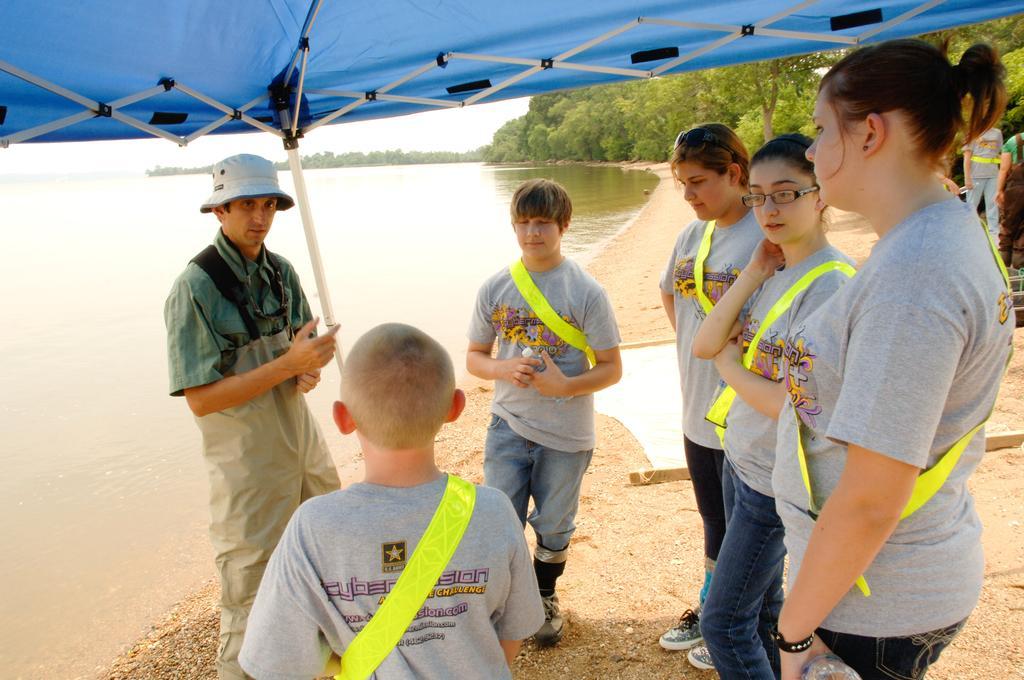How would you summarize this image in a sentence or two? In this picture we can see some people are standing, on the left side there is water, we can see trees in the background, it looks like a tent at the top of the picture. 